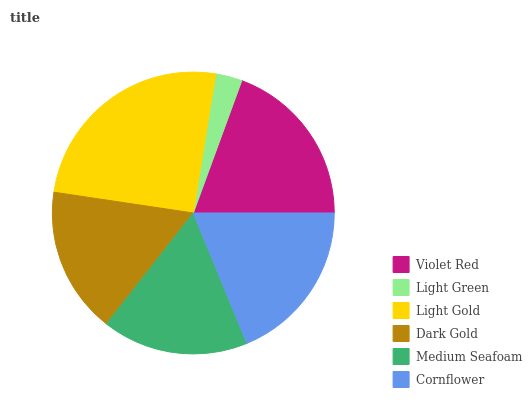Is Light Green the minimum?
Answer yes or no. Yes. Is Light Gold the maximum?
Answer yes or no. Yes. Is Light Gold the minimum?
Answer yes or no. No. Is Light Green the maximum?
Answer yes or no. No. Is Light Gold greater than Light Green?
Answer yes or no. Yes. Is Light Green less than Light Gold?
Answer yes or no. Yes. Is Light Green greater than Light Gold?
Answer yes or no. No. Is Light Gold less than Light Green?
Answer yes or no. No. Is Cornflower the high median?
Answer yes or no. Yes. Is Dark Gold the low median?
Answer yes or no. Yes. Is Dark Gold the high median?
Answer yes or no. No. Is Light Gold the low median?
Answer yes or no. No. 